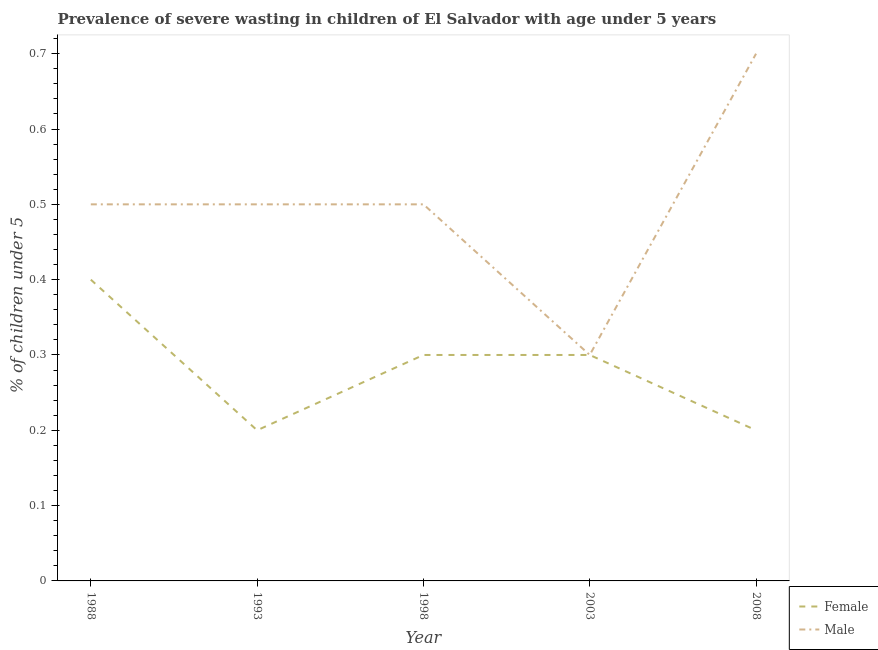Across all years, what is the maximum percentage of undernourished female children?
Ensure brevity in your answer.  0.4. Across all years, what is the minimum percentage of undernourished female children?
Keep it short and to the point. 0.2. In which year was the percentage of undernourished female children maximum?
Provide a succinct answer. 1988. In which year was the percentage of undernourished female children minimum?
Your answer should be very brief. 1993. What is the difference between the percentage of undernourished female children in 1993 and that in 1998?
Your answer should be compact. -0.1. What is the difference between the percentage of undernourished female children in 1998 and the percentage of undernourished male children in 2008?
Make the answer very short. -0.4. What is the average percentage of undernourished female children per year?
Give a very brief answer. 0.28. In the year 1988, what is the difference between the percentage of undernourished female children and percentage of undernourished male children?
Keep it short and to the point. -0.1. In how many years, is the percentage of undernourished male children greater than 0.24000000000000002 %?
Give a very brief answer. 5. What is the ratio of the percentage of undernourished male children in 2003 to that in 2008?
Keep it short and to the point. 0.43. What is the difference between the highest and the second highest percentage of undernourished male children?
Keep it short and to the point. 0.2. What is the difference between the highest and the lowest percentage of undernourished male children?
Offer a terse response. 0.4. In how many years, is the percentage of undernourished male children greater than the average percentage of undernourished male children taken over all years?
Your answer should be compact. 1. Is the sum of the percentage of undernourished male children in 1993 and 2008 greater than the maximum percentage of undernourished female children across all years?
Give a very brief answer. Yes. Does the percentage of undernourished female children monotonically increase over the years?
Your response must be concise. No. What is the difference between two consecutive major ticks on the Y-axis?
Your answer should be compact. 0.1. Are the values on the major ticks of Y-axis written in scientific E-notation?
Make the answer very short. No. Does the graph contain any zero values?
Give a very brief answer. No. Does the graph contain grids?
Give a very brief answer. No. How many legend labels are there?
Make the answer very short. 2. How are the legend labels stacked?
Keep it short and to the point. Vertical. What is the title of the graph?
Offer a terse response. Prevalence of severe wasting in children of El Salvador with age under 5 years. What is the label or title of the Y-axis?
Ensure brevity in your answer.   % of children under 5. What is the  % of children under 5 of Female in 1988?
Offer a very short reply. 0.4. What is the  % of children under 5 of Male in 1988?
Provide a short and direct response. 0.5. What is the  % of children under 5 in Female in 1993?
Your response must be concise. 0.2. What is the  % of children under 5 of Male in 1993?
Your answer should be compact. 0.5. What is the  % of children under 5 in Female in 1998?
Offer a very short reply. 0.3. What is the  % of children under 5 of Male in 1998?
Your response must be concise. 0.5. What is the  % of children under 5 of Female in 2003?
Offer a terse response. 0.3. What is the  % of children under 5 in Male in 2003?
Provide a succinct answer. 0.3. What is the  % of children under 5 in Female in 2008?
Give a very brief answer. 0.2. What is the  % of children under 5 of Male in 2008?
Keep it short and to the point. 0.7. Across all years, what is the maximum  % of children under 5 of Female?
Offer a very short reply. 0.4. Across all years, what is the maximum  % of children under 5 of Male?
Your answer should be compact. 0.7. Across all years, what is the minimum  % of children under 5 of Female?
Offer a terse response. 0.2. Across all years, what is the minimum  % of children under 5 in Male?
Make the answer very short. 0.3. What is the total  % of children under 5 of Male in the graph?
Provide a succinct answer. 2.5. What is the difference between the  % of children under 5 in Female in 1988 and that in 1993?
Offer a very short reply. 0.2. What is the difference between the  % of children under 5 of Male in 1988 and that in 1993?
Your response must be concise. 0. What is the difference between the  % of children under 5 of Female in 1988 and that in 1998?
Make the answer very short. 0.1. What is the difference between the  % of children under 5 of Female in 1988 and that in 2008?
Give a very brief answer. 0.2. What is the difference between the  % of children under 5 in Male in 1988 and that in 2008?
Ensure brevity in your answer.  -0.2. What is the difference between the  % of children under 5 of Female in 1993 and that in 1998?
Provide a short and direct response. -0.1. What is the difference between the  % of children under 5 of Male in 1993 and that in 2003?
Ensure brevity in your answer.  0.2. What is the difference between the  % of children under 5 of Female in 1998 and that in 2003?
Provide a short and direct response. 0. What is the difference between the  % of children under 5 in Male in 1998 and that in 2003?
Offer a very short reply. 0.2. What is the difference between the  % of children under 5 of Female in 1998 and that in 2008?
Your answer should be compact. 0.1. What is the difference between the  % of children under 5 in Male in 2003 and that in 2008?
Your response must be concise. -0.4. What is the difference between the  % of children under 5 of Female in 1988 and the  % of children under 5 of Male in 1993?
Provide a succinct answer. -0.1. What is the difference between the  % of children under 5 of Female in 1988 and the  % of children under 5 of Male in 2008?
Give a very brief answer. -0.3. What is the difference between the  % of children under 5 of Female in 1993 and the  % of children under 5 of Male in 1998?
Make the answer very short. -0.3. What is the difference between the  % of children under 5 of Female in 1998 and the  % of children under 5 of Male in 2003?
Give a very brief answer. 0. What is the difference between the  % of children under 5 of Female in 2003 and the  % of children under 5 of Male in 2008?
Ensure brevity in your answer.  -0.4. What is the average  % of children under 5 of Female per year?
Ensure brevity in your answer.  0.28. What is the average  % of children under 5 of Male per year?
Keep it short and to the point. 0.5. In the year 1993, what is the difference between the  % of children under 5 in Female and  % of children under 5 in Male?
Offer a very short reply. -0.3. In the year 1998, what is the difference between the  % of children under 5 of Female and  % of children under 5 of Male?
Offer a terse response. -0.2. In the year 2003, what is the difference between the  % of children under 5 in Female and  % of children under 5 in Male?
Provide a succinct answer. 0. What is the ratio of the  % of children under 5 of Female in 1988 to that in 1998?
Your response must be concise. 1.33. What is the ratio of the  % of children under 5 of Male in 1993 to that in 1998?
Make the answer very short. 1. What is the ratio of the  % of children under 5 of Female in 1993 to that in 2003?
Provide a short and direct response. 0.67. What is the ratio of the  % of children under 5 of Male in 1993 to that in 2003?
Provide a short and direct response. 1.67. What is the ratio of the  % of children under 5 in Female in 1993 to that in 2008?
Keep it short and to the point. 1. What is the ratio of the  % of children under 5 in Male in 1998 to that in 2003?
Give a very brief answer. 1.67. What is the ratio of the  % of children under 5 of Female in 1998 to that in 2008?
Provide a succinct answer. 1.5. What is the ratio of the  % of children under 5 in Male in 1998 to that in 2008?
Ensure brevity in your answer.  0.71. What is the ratio of the  % of children under 5 in Female in 2003 to that in 2008?
Give a very brief answer. 1.5. What is the ratio of the  % of children under 5 of Male in 2003 to that in 2008?
Offer a very short reply. 0.43. What is the difference between the highest and the second highest  % of children under 5 in Male?
Your answer should be compact. 0.2. What is the difference between the highest and the lowest  % of children under 5 in Male?
Give a very brief answer. 0.4. 